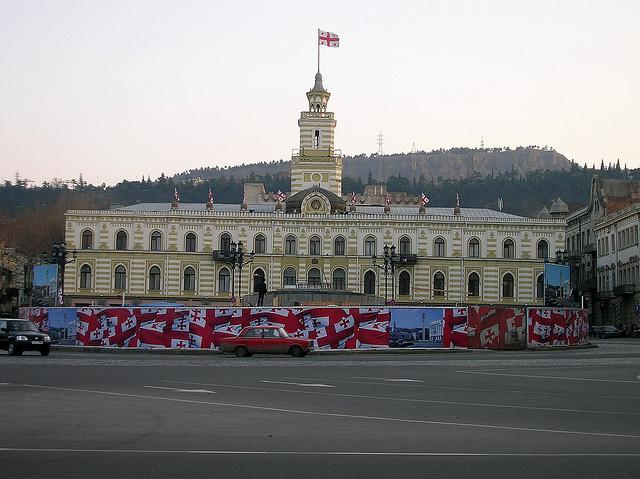Does the car blend into the background?
Short answer required. Yes. What is the red object?
Be succinct. Car. What country's flag is flying?
Give a very brief answer. Switzerland. Is there a clock on the building?
Write a very short answer. Yes. 